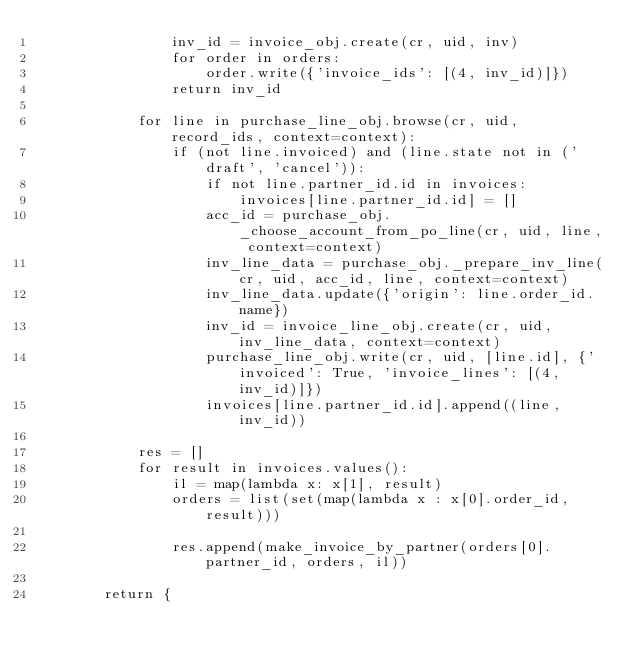Convert code to text. <code><loc_0><loc_0><loc_500><loc_500><_Python_>                inv_id = invoice_obj.create(cr, uid, inv)
                for order in orders:
                    order.write({'invoice_ids': [(4, inv_id)]})
                return inv_id

            for line in purchase_line_obj.browse(cr, uid, record_ids, context=context):
                if (not line.invoiced) and (line.state not in ('draft', 'cancel')):
                    if not line.partner_id.id in invoices:
                        invoices[line.partner_id.id] = []
                    acc_id = purchase_obj._choose_account_from_po_line(cr, uid, line, context=context)
                    inv_line_data = purchase_obj._prepare_inv_line(cr, uid, acc_id, line, context=context)
                    inv_line_data.update({'origin': line.order_id.name})
                    inv_id = invoice_line_obj.create(cr, uid, inv_line_data, context=context)
                    purchase_line_obj.write(cr, uid, [line.id], {'invoiced': True, 'invoice_lines': [(4, inv_id)]})
                    invoices[line.partner_id.id].append((line,inv_id))

            res = []
            for result in invoices.values():
                il = map(lambda x: x[1], result)
                orders = list(set(map(lambda x : x[0].order_id, result)))

                res.append(make_invoice_by_partner(orders[0].partner_id, orders, il))

        return {</code> 